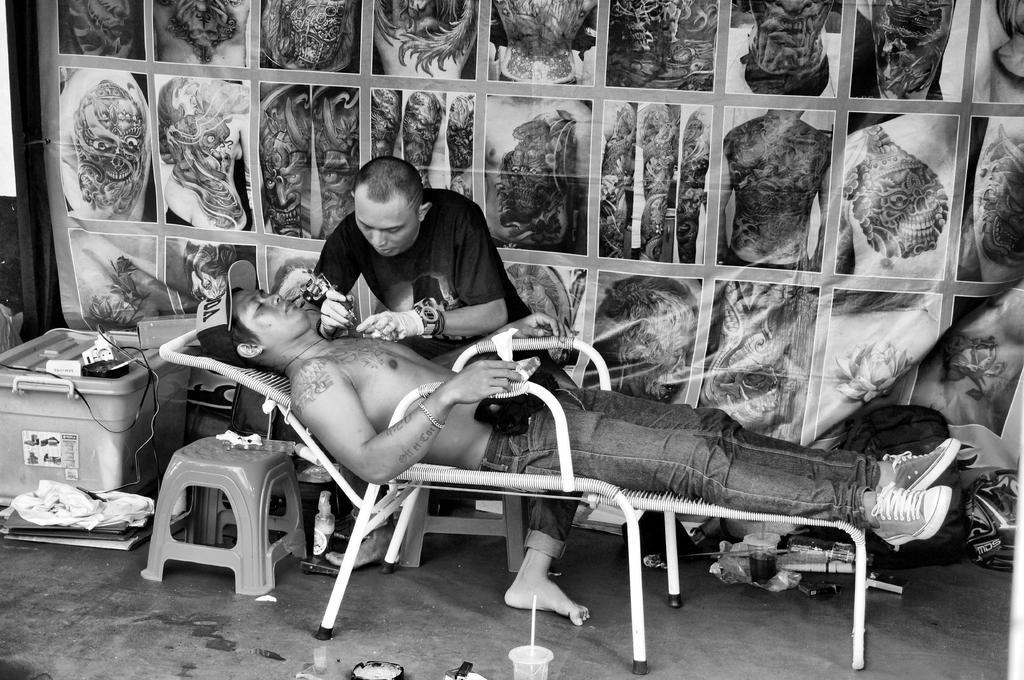How would you summarize this image in a sentence or two? In this image there is a man sleeping on the chair, there is a man sitting on the stool, he is holding an object, there are objects on the ground, there are objects towards the bottom of the image, there is a bag on the ground, there is a banner behind the man. 